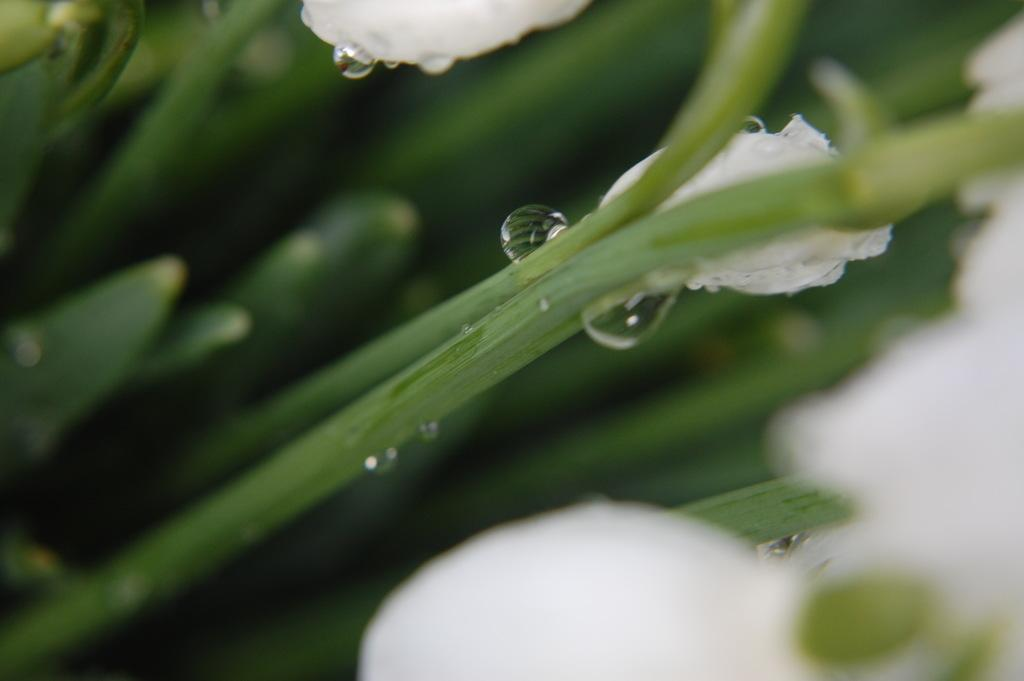What type of objects can be seen in the image with stems? There are water droplets and petals in the image with stems. What can be inferred about the objects with stems based on the presence of water droplets? The objects with stems might be plants or flowers, as they are often associated with water droplets. What color is the background of the image? The background of the image is green. What might be the primary subject of the image based on the presence of petals? The primary subject of the image might be a flower, as petals are a common feature of flowers. What type of offer is being made by the deer in the image? There is no deer present in the image, so no offer can be made by a deer. 